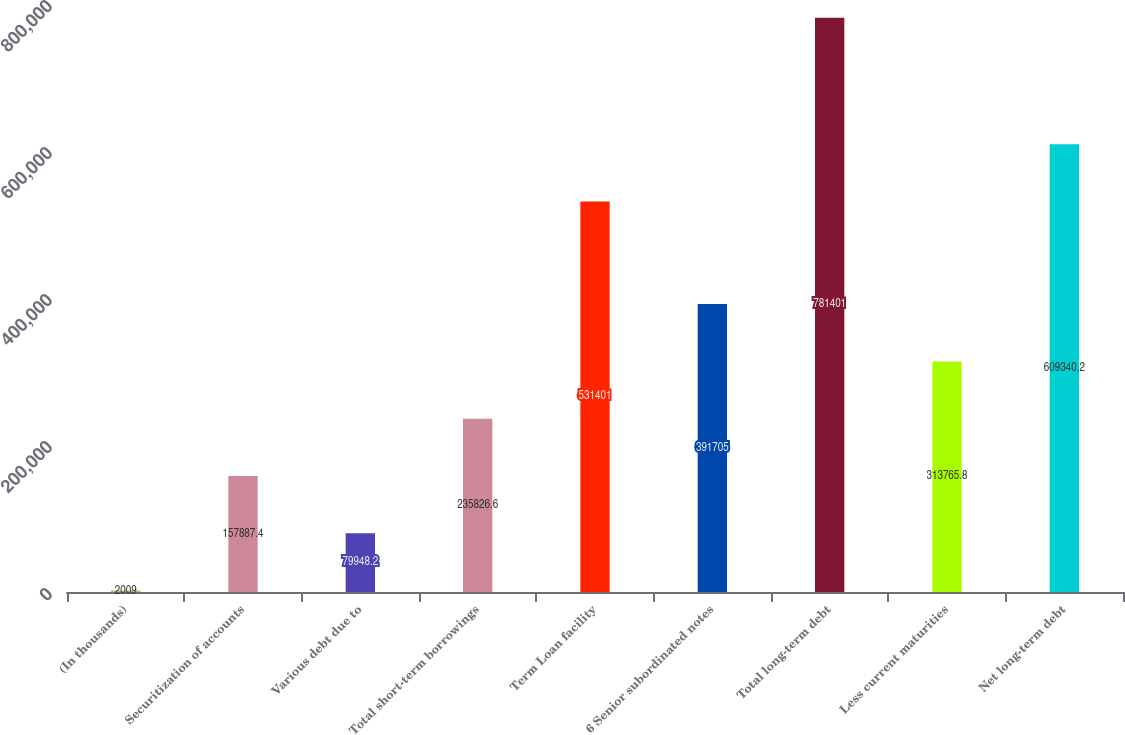<chart> <loc_0><loc_0><loc_500><loc_500><bar_chart><fcel>(In thousands)<fcel>Securitization of accounts<fcel>Various debt due to<fcel>Total short-term borrowings<fcel>Term Loan facility<fcel>6 Senior subordinated notes<fcel>Total long-term debt<fcel>Less current maturities<fcel>Net long-term debt<nl><fcel>2009<fcel>157887<fcel>79948.2<fcel>235827<fcel>531401<fcel>391705<fcel>781401<fcel>313766<fcel>609340<nl></chart> 